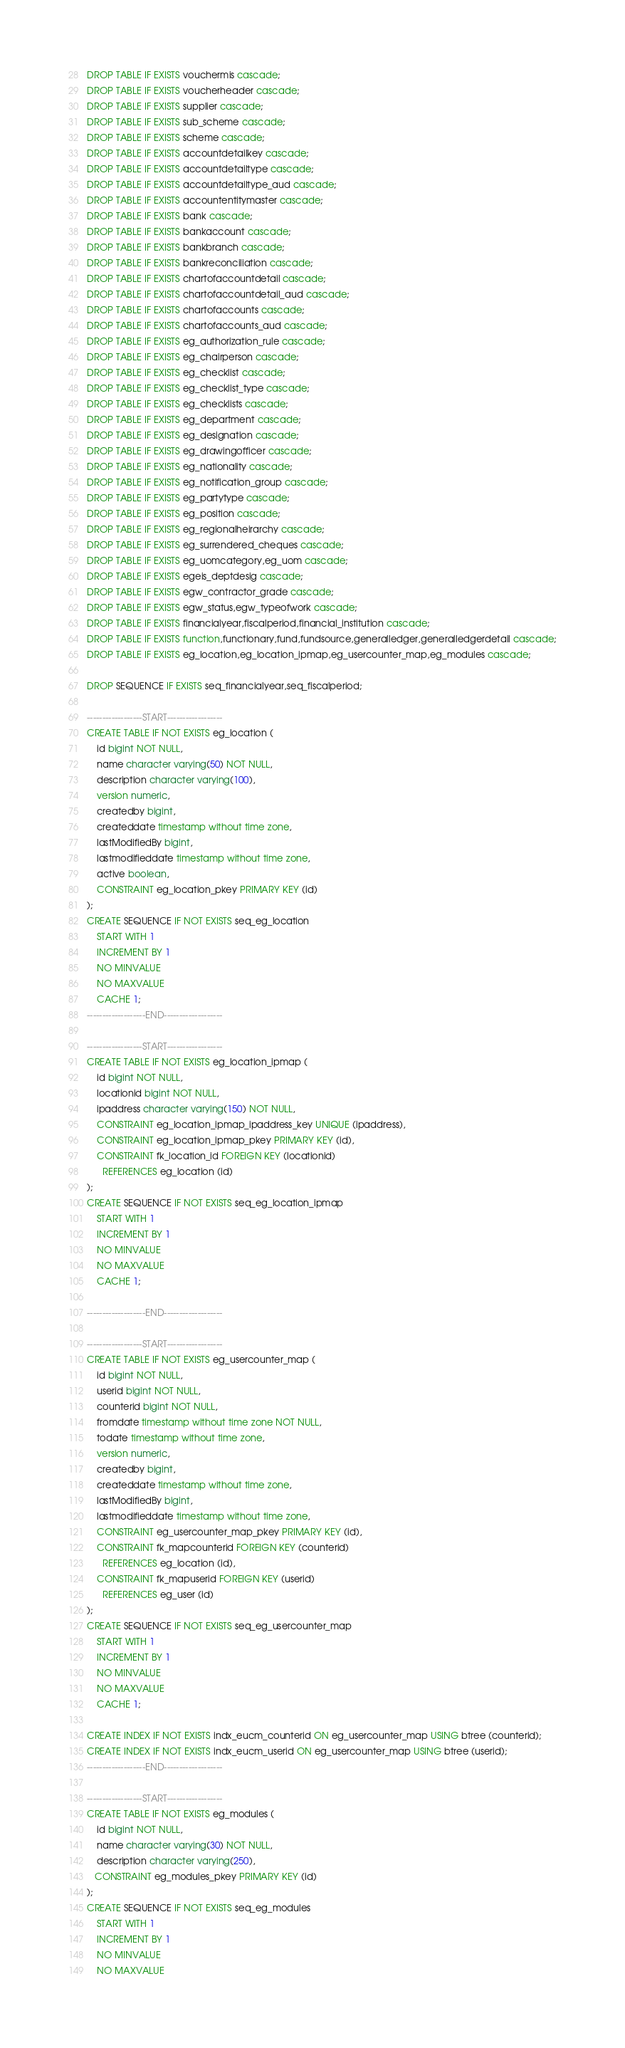Convert code to text. <code><loc_0><loc_0><loc_500><loc_500><_SQL_>DROP TABLE IF EXISTS vouchermis cascade;
DROP TABLE IF EXISTS voucherheader cascade;
DROP TABLE IF EXISTS supplier cascade;
DROP TABLE IF EXISTS sub_scheme cascade;
DROP TABLE IF EXISTS scheme cascade;
DROP TABLE IF EXISTS accountdetailkey cascade;
DROP TABLE IF EXISTS accountdetailtype cascade;
DROP TABLE IF EXISTS accountdetailtype_aud cascade;
DROP TABLE IF EXISTS accountentitymaster cascade;
DROP TABLE IF EXISTS bank cascade;
DROP TABLE IF EXISTS bankaccount cascade;
DROP TABLE IF EXISTS bankbranch cascade;
DROP TABLE IF EXISTS bankreconciliation cascade;
DROP TABLE IF EXISTS chartofaccountdetail cascade;
DROP TABLE IF EXISTS chartofaccountdetail_aud cascade;
DROP TABLE IF EXISTS chartofaccounts cascade;
DROP TABLE IF EXISTS chartofaccounts_aud cascade;
DROP TABLE IF EXISTS eg_authorization_rule cascade;
DROP TABLE IF EXISTS eg_chairperson cascade;
DROP TABLE IF EXISTS eg_checklist cascade;
DROP TABLE IF EXISTS eg_checklist_type cascade;
DROP TABLE IF EXISTS eg_checklists cascade;
DROP TABLE IF EXISTS eg_department cascade;
DROP TABLE IF EXISTS eg_designation cascade;
DROP TABLE IF EXISTS eg_drawingofficer cascade;
DROP TABLE IF EXISTS eg_nationality cascade;
DROP TABLE IF EXISTS eg_notification_group cascade;
DROP TABLE IF EXISTS eg_partytype cascade;
DROP TABLE IF EXISTS eg_position cascade;
DROP TABLE IF EXISTS eg_regionalheirarchy cascade;
DROP TABLE IF EXISTS eg_surrendered_cheques cascade;
DROP TABLE IF EXISTS eg_uomcategory,eg_uom cascade;
DROP TABLE IF EXISTS egeis_deptdesig cascade;
DROP TABLE IF EXISTS egw_contractor_grade cascade;
DROP TABLE IF EXISTS egw_status,egw_typeofwork cascade;
DROP TABLE IF EXISTS financialyear,fiscalperiod,financial_institution cascade;
DROP TABLE IF EXISTS function,functionary,fund,fundsource,generalledger,generalledgerdetail cascade;
DROP TABLE IF EXISTS eg_location,eg_location_ipmap,eg_usercounter_map,eg_modules cascade;

DROP SEQUENCE IF EXISTS seq_financialyear,seq_fiscalperiod;

------------------START------------------
CREATE TABLE IF NOT EXISTS eg_location (
    id bigint NOT NULL,
    name character varying(50) NOT NULL,
    description character varying(100),
    version numeric,
    createdby bigint,
    createddate timestamp without time zone,
    lastModifiedBy bigint,
    lastmodifieddate timestamp without time zone,
    active boolean,
    CONSTRAINT eg_location_pkey PRIMARY KEY (id)
);
CREATE SEQUENCE IF NOT EXISTS seq_eg_location
    START WITH 1
    INCREMENT BY 1
    NO MINVALUE
    NO MAXVALUE
    CACHE 1;
-------------------END-------------------

------------------START------------------
CREATE TABLE IF NOT EXISTS eg_location_ipmap (
    id bigint NOT NULL,
    locationid bigint NOT NULL,
    ipaddress character varying(150) NOT NULL,
    CONSTRAINT eg_location_ipmap_ipaddress_key UNIQUE (ipaddress),
    CONSTRAINT eg_location_ipmap_pkey PRIMARY KEY (id),
    CONSTRAINT fk_location_id FOREIGN KEY (locationid)
      REFERENCES eg_location (id)
);
CREATE SEQUENCE IF NOT EXISTS seq_eg_location_ipmap
    START WITH 1
    INCREMENT BY 1
    NO MINVALUE
    NO MAXVALUE
    CACHE 1;

-------------------END-------------------

------------------START------------------
CREATE TABLE IF NOT EXISTS eg_usercounter_map (
    id bigint NOT NULL,
    userid bigint NOT NULL,
    counterid bigint NOT NULL,
    fromdate timestamp without time zone NOT NULL,
    todate timestamp without time zone,
    version numeric,
    createdby bigint,
    createddate timestamp without time zone,
    lastModifiedBy bigint,
    lastmodifieddate timestamp without time zone,
    CONSTRAINT eg_usercounter_map_pkey PRIMARY KEY (id),
    CONSTRAINT fk_mapcounterid FOREIGN KEY (counterid)
      REFERENCES eg_location (id),
    CONSTRAINT fk_mapuserid FOREIGN KEY (userid)
      REFERENCES eg_user (id)
);
CREATE SEQUENCE IF NOT EXISTS seq_eg_usercounter_map
    START WITH 1
    INCREMENT BY 1
    NO MINVALUE
    NO MAXVALUE
    CACHE 1;

CREATE INDEX IF NOT EXISTS indx_eucm_counterid ON eg_usercounter_map USING btree (counterid);
CREATE INDEX IF NOT EXISTS indx_eucm_userid ON eg_usercounter_map USING btree (userid);
-------------------END-------------------

------------------START------------------
CREATE TABLE IF NOT EXISTS eg_modules (
    id bigint NOT NULL,
    name character varying(30) NOT NULL,
    description character varying(250),
   CONSTRAINT eg_modules_pkey PRIMARY KEY (id)
);
CREATE SEQUENCE IF NOT EXISTS seq_eg_modules
    START WITH 1
    INCREMENT BY 1
    NO MINVALUE
    NO MAXVALUE</code> 